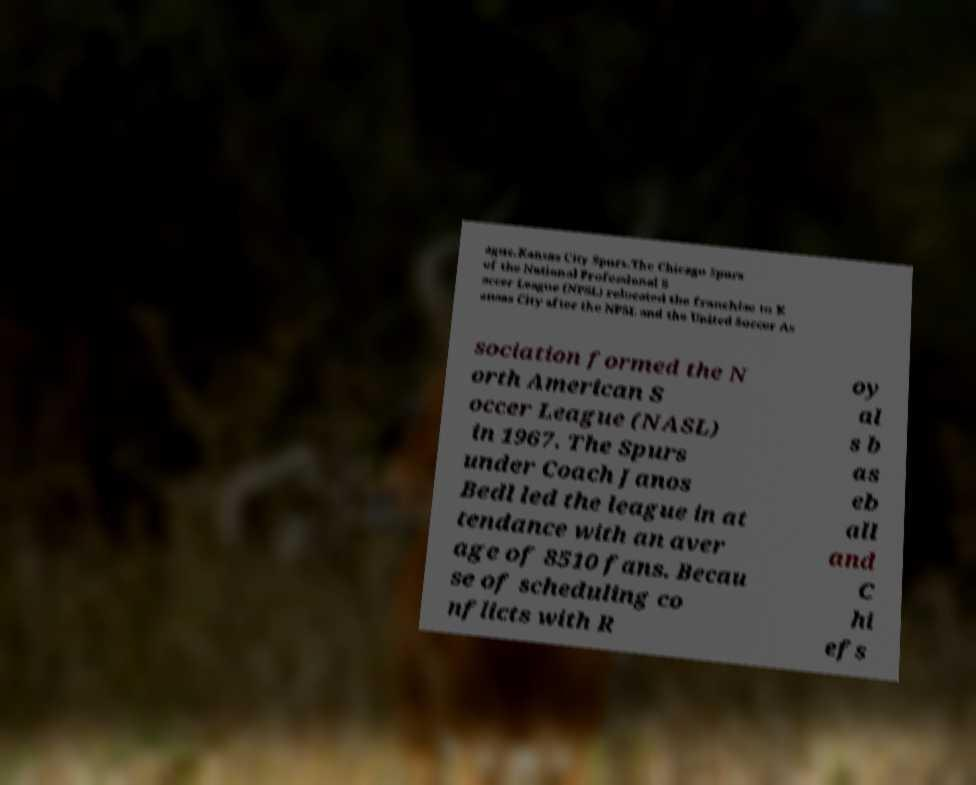Can you accurately transcribe the text from the provided image for me? ague.Kansas City Spurs.The Chicago Spurs of the National Professional S occer League (NPSL) relocated the franchise to K ansas City after the NPSL and the United Soccer As sociation formed the N orth American S occer League (NASL) in 1967. The Spurs under Coach Janos Bedl led the league in at tendance with an aver age of 8510 fans. Becau se of scheduling co nflicts with R oy al s b as eb all and C hi efs 